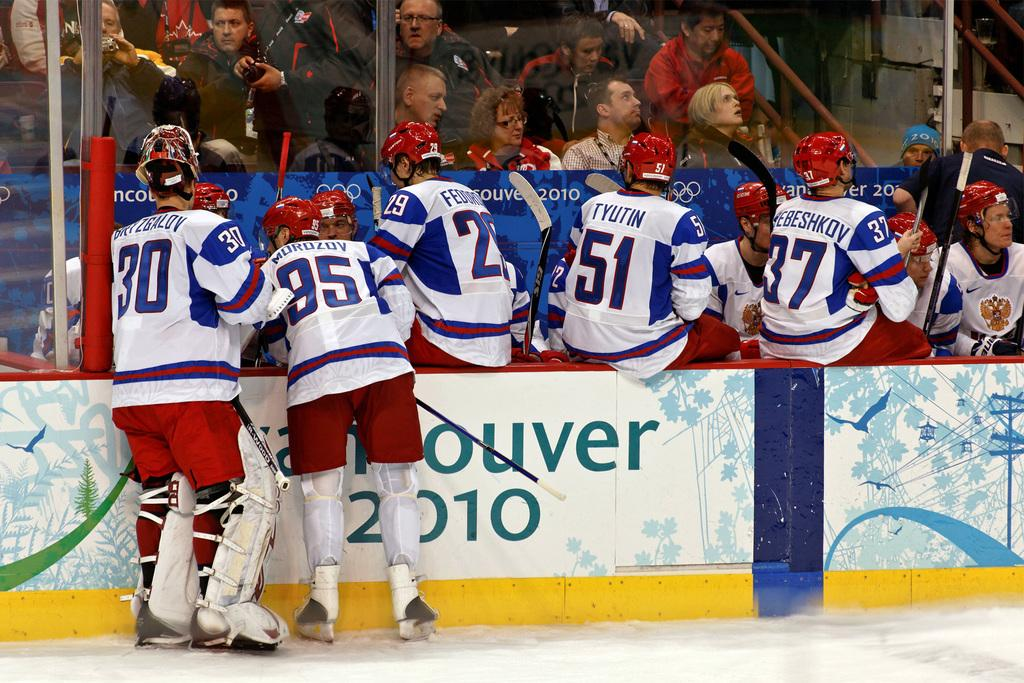<image>
Present a compact description of the photo's key features. A hockey team sits around in front of a Vancouver 2010 sign. 